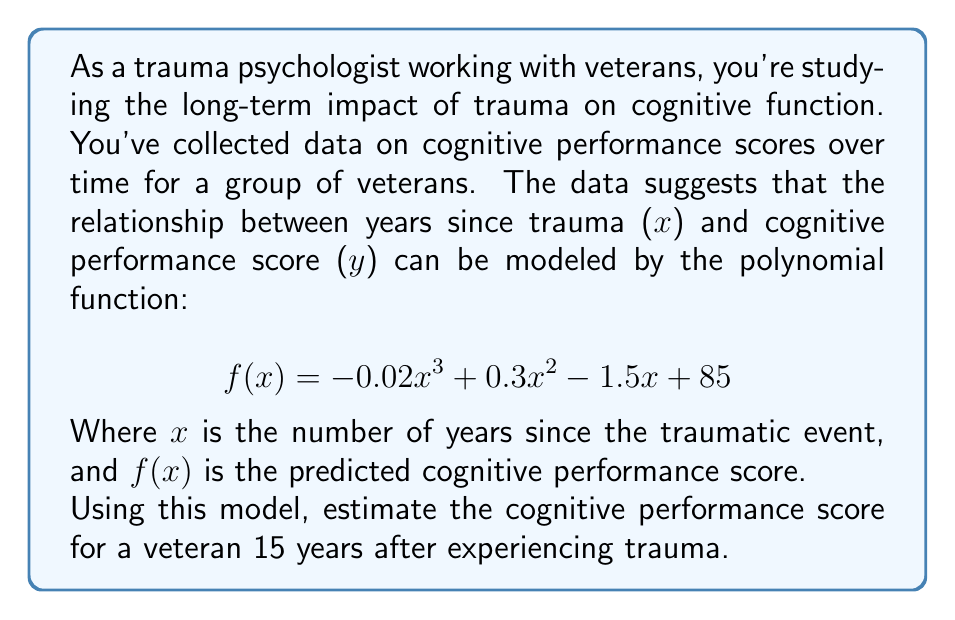Show me your answer to this math problem. To solve this problem, we need to evaluate the given polynomial function at x = 15. Let's break it down step-by-step:

1) The given function is:
   $$ f(x) = -0.02x^3 + 0.3x^2 - 1.5x + 85 $$

2) We need to calculate f(15). Let's substitute x with 15:
   $$ f(15) = -0.02(15)^3 + 0.3(15)^2 - 1.5(15) + 85 $$

3) Let's evaluate each term:
   a) $-0.02(15)^3 = -0.02 \cdot 3375 = -67.5$
   b) $0.3(15)^2 = 0.3 \cdot 225 = 67.5$
   c) $-1.5(15) = -22.5$
   d) The constant term is 85

4) Now, let's add all these terms:
   $$ f(15) = -67.5 + 67.5 - 22.5 + 85 = 62.5 $$

Therefore, the estimated cognitive performance score for a veteran 15 years after experiencing trauma is 62.5.
Answer: 62.5 